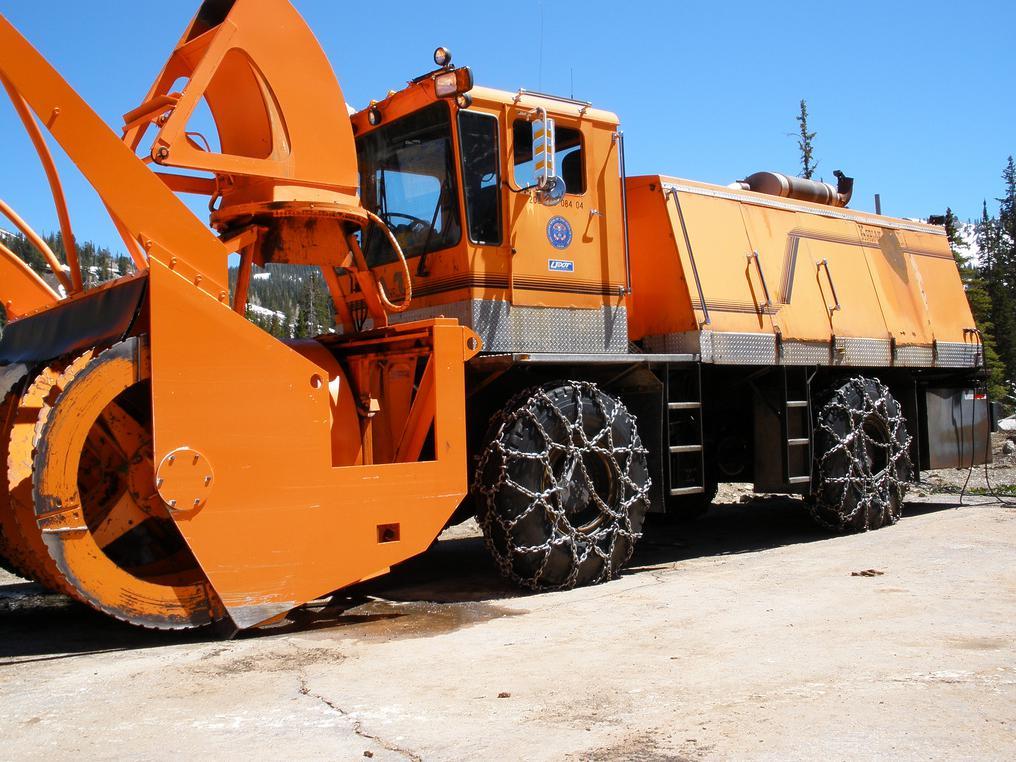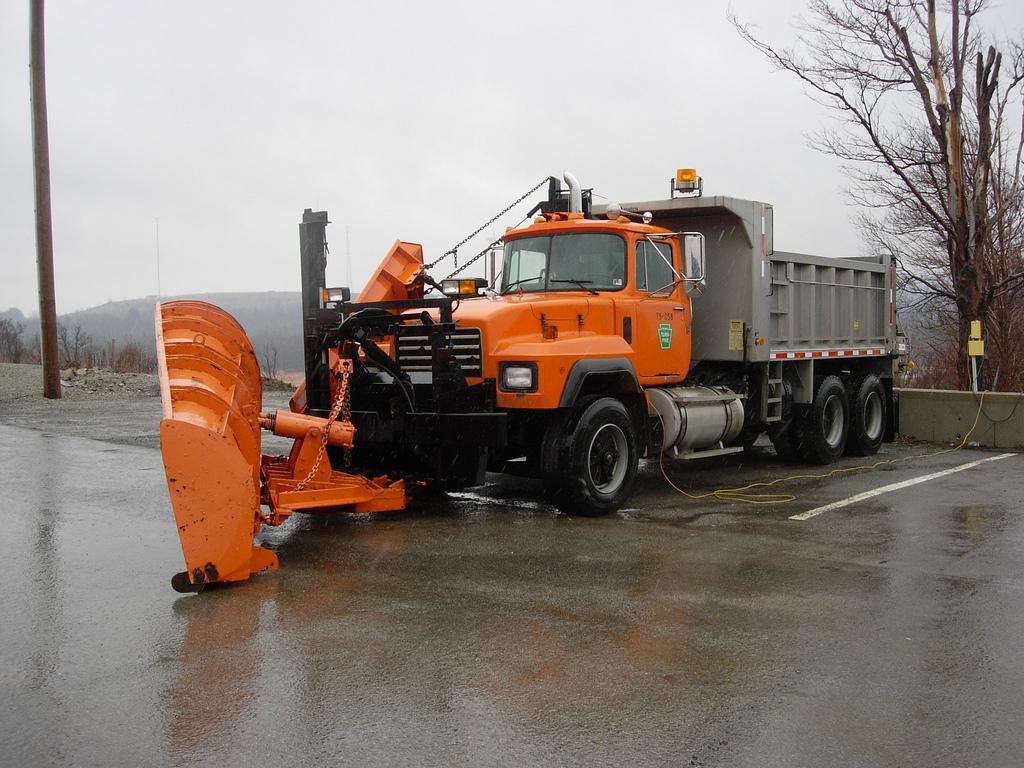The first image is the image on the left, the second image is the image on the right. For the images shown, is this caption "An image shows multiple trucks with golden-yellow cabs and beds parked in a dry paved area." true? Answer yes or no. No. The first image is the image on the left, the second image is the image on the right. Assess this claim about the two images: "There are two bulldozers both facing left.". Correct or not? Answer yes or no. Yes. 